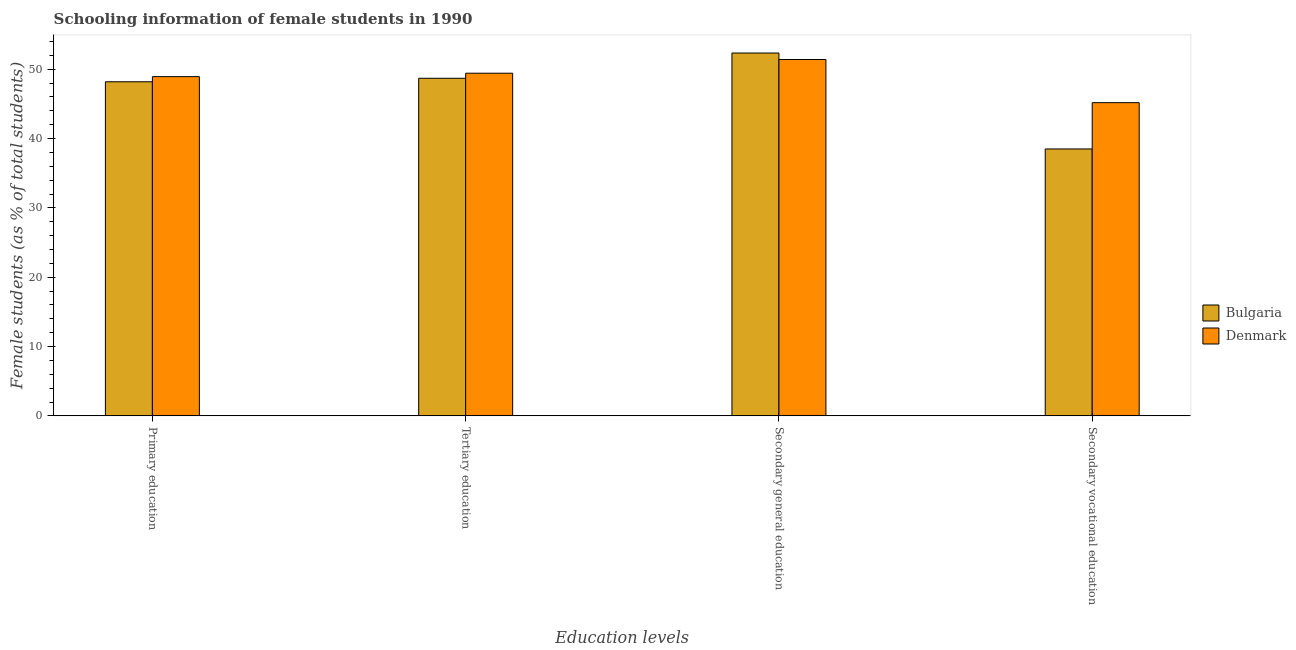How many different coloured bars are there?
Keep it short and to the point. 2. How many groups of bars are there?
Give a very brief answer. 4. Are the number of bars per tick equal to the number of legend labels?
Provide a succinct answer. Yes. Are the number of bars on each tick of the X-axis equal?
Make the answer very short. Yes. How many bars are there on the 3rd tick from the right?
Make the answer very short. 2. What is the label of the 4th group of bars from the left?
Provide a succinct answer. Secondary vocational education. What is the percentage of female students in secondary vocational education in Bulgaria?
Keep it short and to the point. 38.5. Across all countries, what is the maximum percentage of female students in primary education?
Keep it short and to the point. 48.93. Across all countries, what is the minimum percentage of female students in tertiary education?
Offer a very short reply. 48.7. In which country was the percentage of female students in secondary vocational education minimum?
Give a very brief answer. Bulgaria. What is the total percentage of female students in tertiary education in the graph?
Provide a short and direct response. 98.12. What is the difference between the percentage of female students in secondary education in Bulgaria and that in Denmark?
Provide a short and direct response. 0.93. What is the difference between the percentage of female students in primary education in Denmark and the percentage of female students in tertiary education in Bulgaria?
Provide a succinct answer. 0.24. What is the average percentage of female students in secondary vocational education per country?
Your answer should be compact. 41.84. What is the difference between the percentage of female students in secondary vocational education and percentage of female students in secondary education in Bulgaria?
Provide a short and direct response. -13.84. In how many countries, is the percentage of female students in secondary vocational education greater than 38 %?
Your response must be concise. 2. What is the ratio of the percentage of female students in tertiary education in Bulgaria to that in Denmark?
Offer a terse response. 0.99. What is the difference between the highest and the second highest percentage of female students in tertiary education?
Your answer should be very brief. 0.73. What is the difference between the highest and the lowest percentage of female students in secondary education?
Your answer should be compact. 0.93. In how many countries, is the percentage of female students in secondary vocational education greater than the average percentage of female students in secondary vocational education taken over all countries?
Provide a succinct answer. 1. Is it the case that in every country, the sum of the percentage of female students in primary education and percentage of female students in tertiary education is greater than the sum of percentage of female students in secondary education and percentage of female students in secondary vocational education?
Make the answer very short. Yes. Is it the case that in every country, the sum of the percentage of female students in primary education and percentage of female students in tertiary education is greater than the percentage of female students in secondary education?
Provide a short and direct response. Yes. What is the difference between two consecutive major ticks on the Y-axis?
Provide a short and direct response. 10. What is the title of the graph?
Ensure brevity in your answer.  Schooling information of female students in 1990. What is the label or title of the X-axis?
Your answer should be compact. Education levels. What is the label or title of the Y-axis?
Give a very brief answer. Female students (as % of total students). What is the Female students (as % of total students) of Bulgaria in Primary education?
Your response must be concise. 48.19. What is the Female students (as % of total students) of Denmark in Primary education?
Provide a short and direct response. 48.93. What is the Female students (as % of total students) in Bulgaria in Tertiary education?
Offer a terse response. 48.7. What is the Female students (as % of total students) in Denmark in Tertiary education?
Offer a very short reply. 49.43. What is the Female students (as % of total students) in Bulgaria in Secondary general education?
Give a very brief answer. 52.34. What is the Female students (as % of total students) in Denmark in Secondary general education?
Provide a succinct answer. 51.41. What is the Female students (as % of total students) in Bulgaria in Secondary vocational education?
Make the answer very short. 38.5. What is the Female students (as % of total students) of Denmark in Secondary vocational education?
Your answer should be compact. 45.18. Across all Education levels, what is the maximum Female students (as % of total students) of Bulgaria?
Your response must be concise. 52.34. Across all Education levels, what is the maximum Female students (as % of total students) in Denmark?
Give a very brief answer. 51.41. Across all Education levels, what is the minimum Female students (as % of total students) of Bulgaria?
Your response must be concise. 38.5. Across all Education levels, what is the minimum Female students (as % of total students) in Denmark?
Your answer should be compact. 45.18. What is the total Female students (as % of total students) of Bulgaria in the graph?
Your answer should be very brief. 187.73. What is the total Female students (as % of total students) in Denmark in the graph?
Your answer should be compact. 194.94. What is the difference between the Female students (as % of total students) of Bulgaria in Primary education and that in Tertiary education?
Offer a very short reply. -0.51. What is the difference between the Female students (as % of total students) in Denmark in Primary education and that in Tertiary education?
Your answer should be very brief. -0.49. What is the difference between the Female students (as % of total students) of Bulgaria in Primary education and that in Secondary general education?
Your answer should be compact. -4.15. What is the difference between the Female students (as % of total students) in Denmark in Primary education and that in Secondary general education?
Provide a succinct answer. -2.47. What is the difference between the Female students (as % of total students) in Bulgaria in Primary education and that in Secondary vocational education?
Provide a short and direct response. 9.69. What is the difference between the Female students (as % of total students) in Denmark in Primary education and that in Secondary vocational education?
Provide a short and direct response. 3.75. What is the difference between the Female students (as % of total students) of Bulgaria in Tertiary education and that in Secondary general education?
Keep it short and to the point. -3.64. What is the difference between the Female students (as % of total students) in Denmark in Tertiary education and that in Secondary general education?
Provide a short and direct response. -1.98. What is the difference between the Female students (as % of total students) in Bulgaria in Tertiary education and that in Secondary vocational education?
Provide a short and direct response. 10.2. What is the difference between the Female students (as % of total students) in Denmark in Tertiary education and that in Secondary vocational education?
Your answer should be compact. 4.25. What is the difference between the Female students (as % of total students) in Bulgaria in Secondary general education and that in Secondary vocational education?
Provide a short and direct response. 13.84. What is the difference between the Female students (as % of total students) of Denmark in Secondary general education and that in Secondary vocational education?
Keep it short and to the point. 6.23. What is the difference between the Female students (as % of total students) in Bulgaria in Primary education and the Female students (as % of total students) in Denmark in Tertiary education?
Give a very brief answer. -1.24. What is the difference between the Female students (as % of total students) in Bulgaria in Primary education and the Female students (as % of total students) in Denmark in Secondary general education?
Offer a terse response. -3.21. What is the difference between the Female students (as % of total students) of Bulgaria in Primary education and the Female students (as % of total students) of Denmark in Secondary vocational education?
Keep it short and to the point. 3.01. What is the difference between the Female students (as % of total students) of Bulgaria in Tertiary education and the Female students (as % of total students) of Denmark in Secondary general education?
Ensure brevity in your answer.  -2.71. What is the difference between the Female students (as % of total students) in Bulgaria in Tertiary education and the Female students (as % of total students) in Denmark in Secondary vocational education?
Give a very brief answer. 3.52. What is the difference between the Female students (as % of total students) of Bulgaria in Secondary general education and the Female students (as % of total students) of Denmark in Secondary vocational education?
Offer a very short reply. 7.16. What is the average Female students (as % of total students) of Bulgaria per Education levels?
Give a very brief answer. 46.93. What is the average Female students (as % of total students) of Denmark per Education levels?
Provide a succinct answer. 48.74. What is the difference between the Female students (as % of total students) of Bulgaria and Female students (as % of total students) of Denmark in Primary education?
Ensure brevity in your answer.  -0.74. What is the difference between the Female students (as % of total students) in Bulgaria and Female students (as % of total students) in Denmark in Tertiary education?
Provide a short and direct response. -0.73. What is the difference between the Female students (as % of total students) in Bulgaria and Female students (as % of total students) in Denmark in Secondary general education?
Keep it short and to the point. 0.93. What is the difference between the Female students (as % of total students) of Bulgaria and Female students (as % of total students) of Denmark in Secondary vocational education?
Your answer should be very brief. -6.68. What is the ratio of the Female students (as % of total students) in Bulgaria in Primary education to that in Secondary general education?
Offer a terse response. 0.92. What is the ratio of the Female students (as % of total students) of Denmark in Primary education to that in Secondary general education?
Ensure brevity in your answer.  0.95. What is the ratio of the Female students (as % of total students) of Bulgaria in Primary education to that in Secondary vocational education?
Provide a succinct answer. 1.25. What is the ratio of the Female students (as % of total students) of Denmark in Primary education to that in Secondary vocational education?
Offer a terse response. 1.08. What is the ratio of the Female students (as % of total students) of Bulgaria in Tertiary education to that in Secondary general education?
Your answer should be compact. 0.93. What is the ratio of the Female students (as % of total students) in Denmark in Tertiary education to that in Secondary general education?
Your answer should be very brief. 0.96. What is the ratio of the Female students (as % of total students) in Bulgaria in Tertiary education to that in Secondary vocational education?
Offer a terse response. 1.26. What is the ratio of the Female students (as % of total students) of Denmark in Tertiary education to that in Secondary vocational education?
Offer a very short reply. 1.09. What is the ratio of the Female students (as % of total students) in Bulgaria in Secondary general education to that in Secondary vocational education?
Give a very brief answer. 1.36. What is the ratio of the Female students (as % of total students) of Denmark in Secondary general education to that in Secondary vocational education?
Your answer should be compact. 1.14. What is the difference between the highest and the second highest Female students (as % of total students) in Bulgaria?
Provide a succinct answer. 3.64. What is the difference between the highest and the second highest Female students (as % of total students) of Denmark?
Your answer should be very brief. 1.98. What is the difference between the highest and the lowest Female students (as % of total students) in Bulgaria?
Keep it short and to the point. 13.84. What is the difference between the highest and the lowest Female students (as % of total students) in Denmark?
Ensure brevity in your answer.  6.23. 